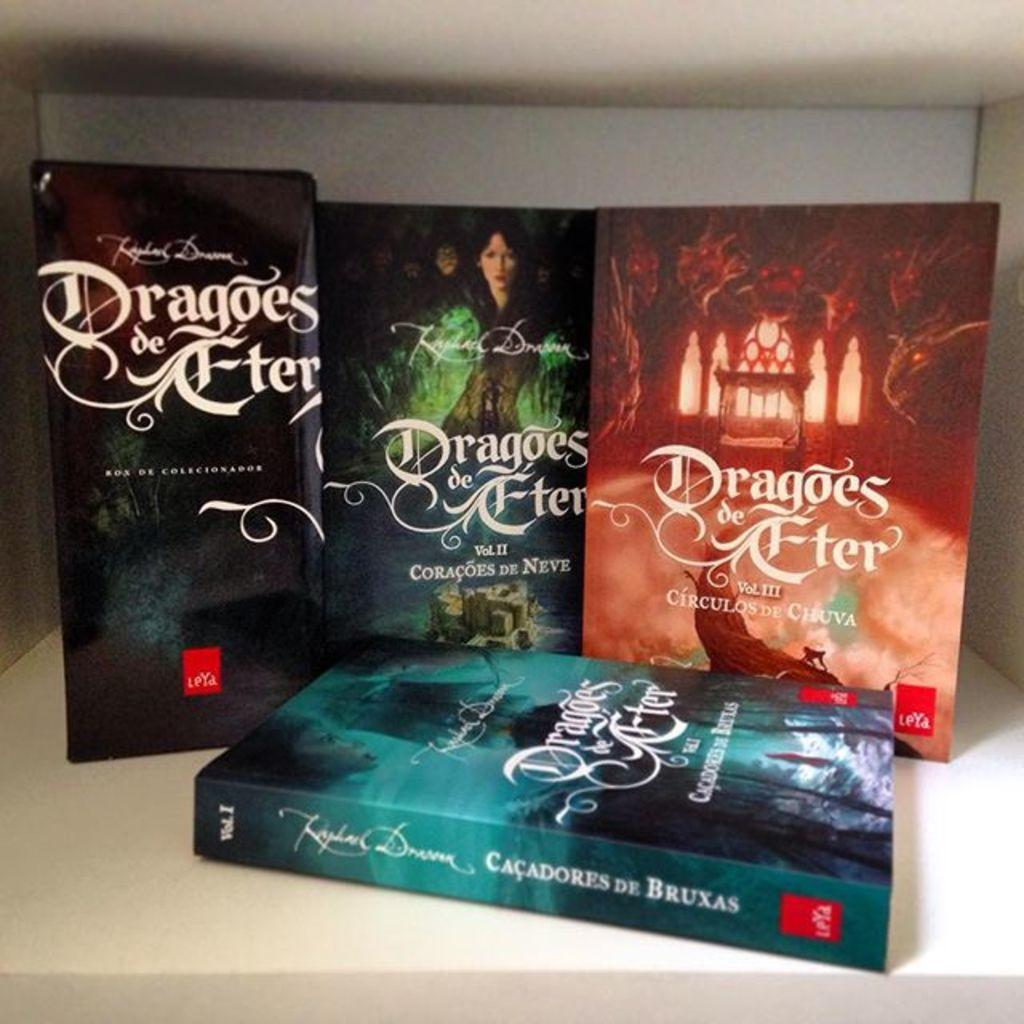<image>
Describe the image concisely. A series of books with the title of Dragoes de Fter. 